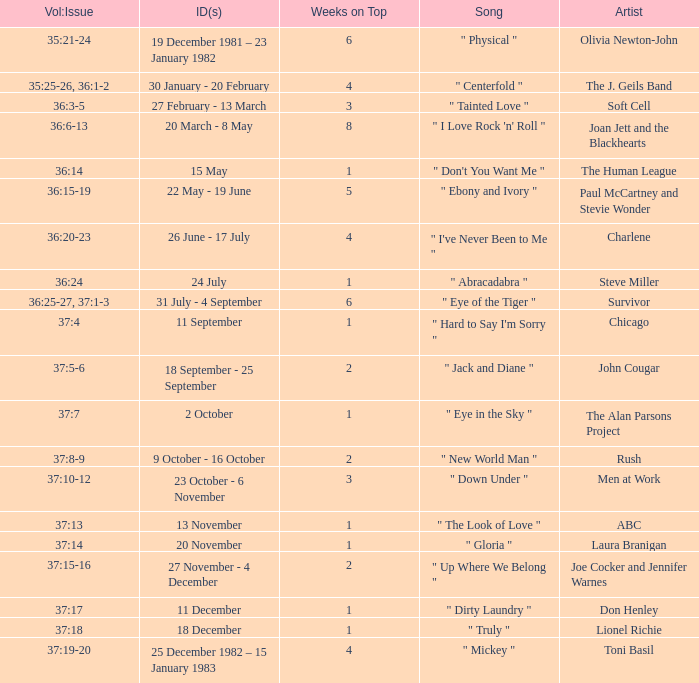Which Issue Date(s) has Weeks on Top larger than 3, and a Volume: Issue of 35:25-26, 36:1-2? 30 January - 20 February. 